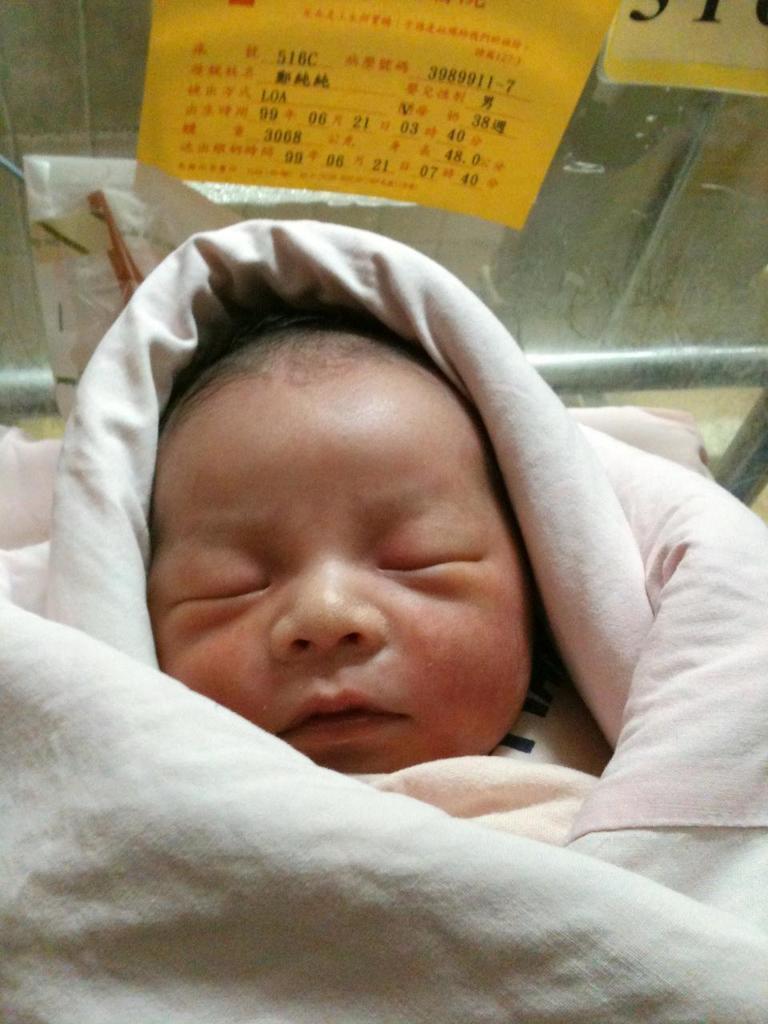Please provide a concise description of this image. In this image we can see a baby sleeping and also we can see a blanket, in the background, we can see the posts with come text on the wall. 